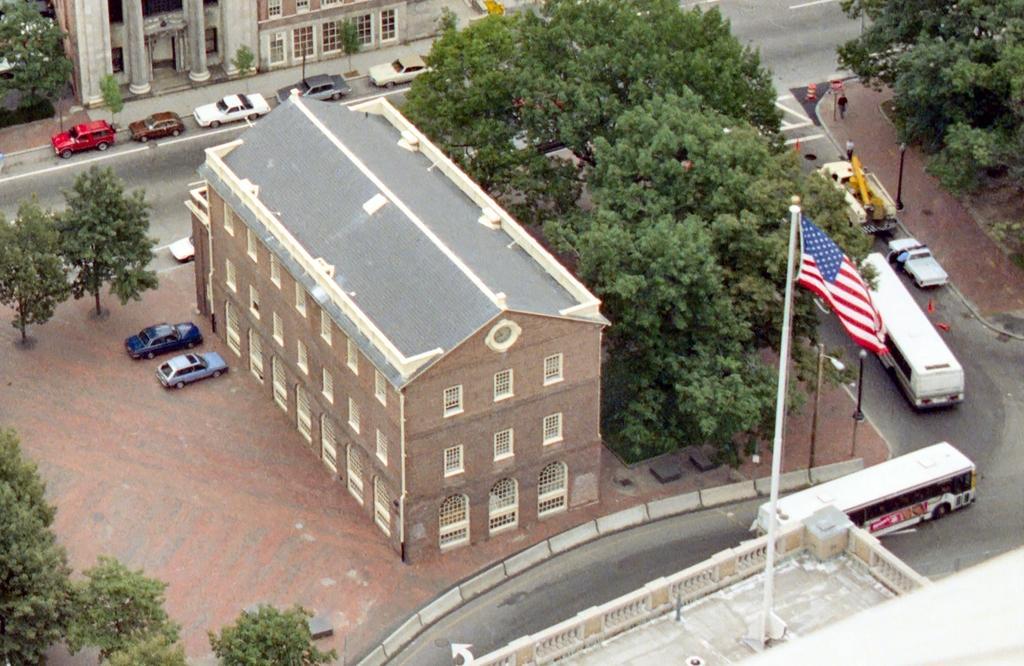Describe this image in one or two sentences. In this image I can see many vehicles are on the road. To the side of the road I can see many trees, buildings, poles and boards. I can see two vehicles in-front of the building and there is a flag on the building. 